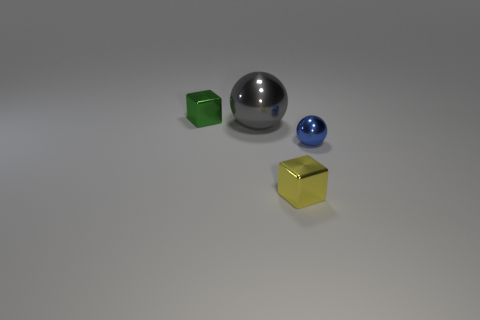Add 4 green matte cylinders. How many objects exist? 8 Subtract all green cubes. How many cubes are left? 1 Add 2 metallic cubes. How many metallic cubes are left? 4 Add 4 tiny blue balls. How many tiny blue balls exist? 5 Subtract 1 green cubes. How many objects are left? 3 Subtract all green spheres. Subtract all purple cylinders. How many spheres are left? 2 Subtract all small yellow things. Subtract all blue metallic objects. How many objects are left? 2 